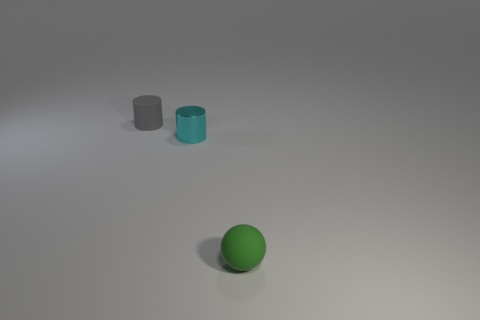What color is the small thing that is the same material as the tiny gray cylinder?
Keep it short and to the point. Green. The cyan object is what shape?
Give a very brief answer. Cylinder. How many other balls have the same color as the tiny ball?
Your response must be concise. 0. There is a matte thing that is the same size as the gray cylinder; what shape is it?
Ensure brevity in your answer.  Sphere. Is there a green rubber cylinder of the same size as the green object?
Offer a very short reply. No. What is the material of the cyan thing that is the same size as the green object?
Make the answer very short. Metal. There is a thing in front of the cylinder that is to the right of the gray matte cylinder; what is its size?
Offer a terse response. Small. Is the size of the rubber object that is on the left side of the cyan cylinder the same as the small cyan cylinder?
Give a very brief answer. Yes. Is the number of matte balls left of the cyan object greater than the number of tiny rubber cylinders to the right of the ball?
Make the answer very short. No. The object that is both to the left of the tiny green rubber ball and in front of the tiny matte cylinder has what shape?
Make the answer very short. Cylinder. 